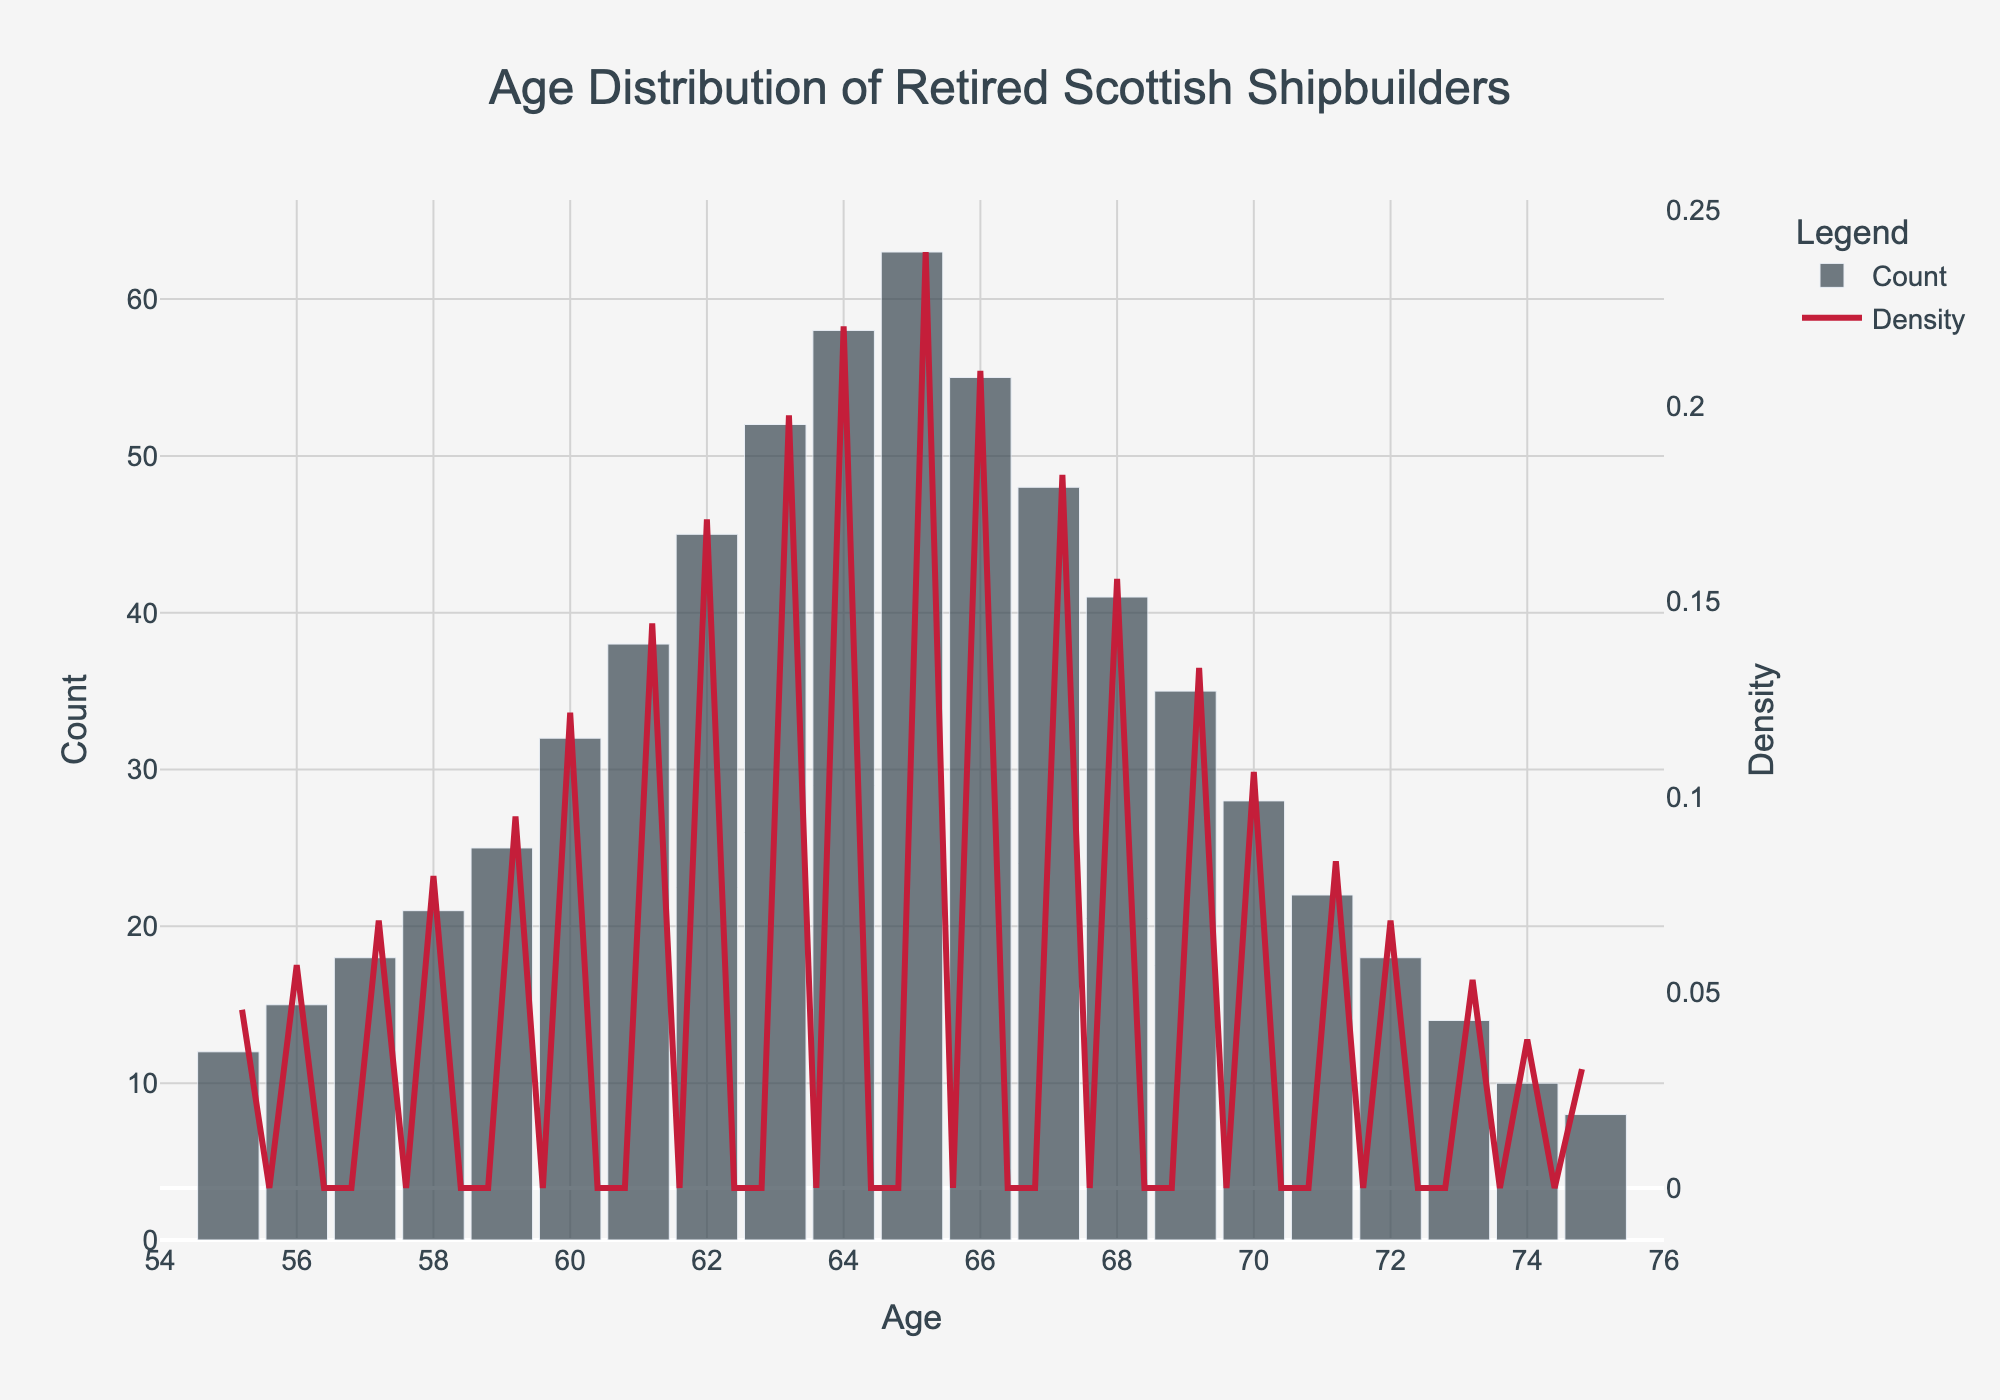What is the title of the plot? The title is located at the top center of the plot. It is specified to describe the data shown in the plot.
Answer: Age Distribution of Retired Scottish Shipbuilders What is the age range displayed on the x-axis? The x-axis range is specified in the code. It spans from 54 to 76.
Answer: 54 to 76 How many retired shipbuilders were aged 65? Referring to the histogram bars, the height above age 65 indicates the count of retired shipbuilders at that age.
Answer: 63 At what age do the majority of the retirees appear to be concentrated? The histogram bar with the highest count determines where the majority of the retirees are concentrated. Look for the highest bar, which is at age 65.
Answer: 65 Which age has the lowest density in the KDE curve? Examine the KDE curve (red line), and find the point where it reaches its minimum value.
Answer: 75 What is the primary color of the bars in the histogram? The color of the bars is specified in the plot design, observed visually as a dark color.
Answer: Dark gray At what age does the KDE curve peak? Locate the highest point on the red KDE curve to identify the corresponding age on the x-axis.
Answer: 65 How many more retired shipbuilders are there at age 62 compared to age 55? Find the histogram counts for ages 62 and 55 and calculate the difference: 45 - 12.
Answer: 33 What trend is noticeable in the histogram from ages 55 to 65? Observing the histogram bars from age 55 to 65, note whether the counts generally increase, decrease, or remain steady. The bars generally increase.
Answer: Increasing trend Is there any age where both the histogram and KDE curve peaks align? Identify if and where the highest bar (histogram peak) and the highest point on the KDE curve (density peak) align along the x-axis.
Answer: Yes, at age 65 